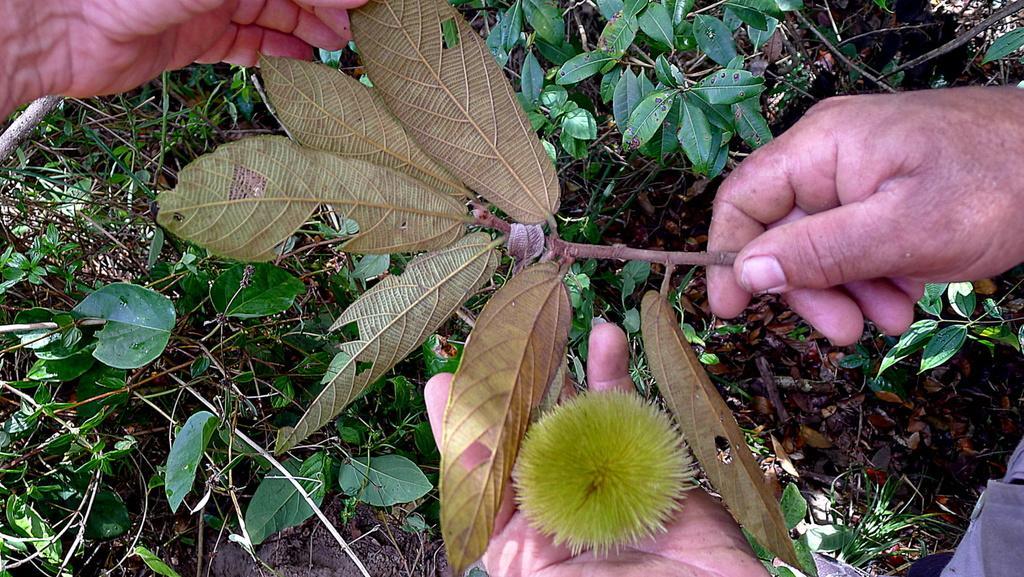Could you give a brief overview of what you see in this image? This is the picture of a person hand in which there is a stem of the plant and also we can see some other plants on the floor. 